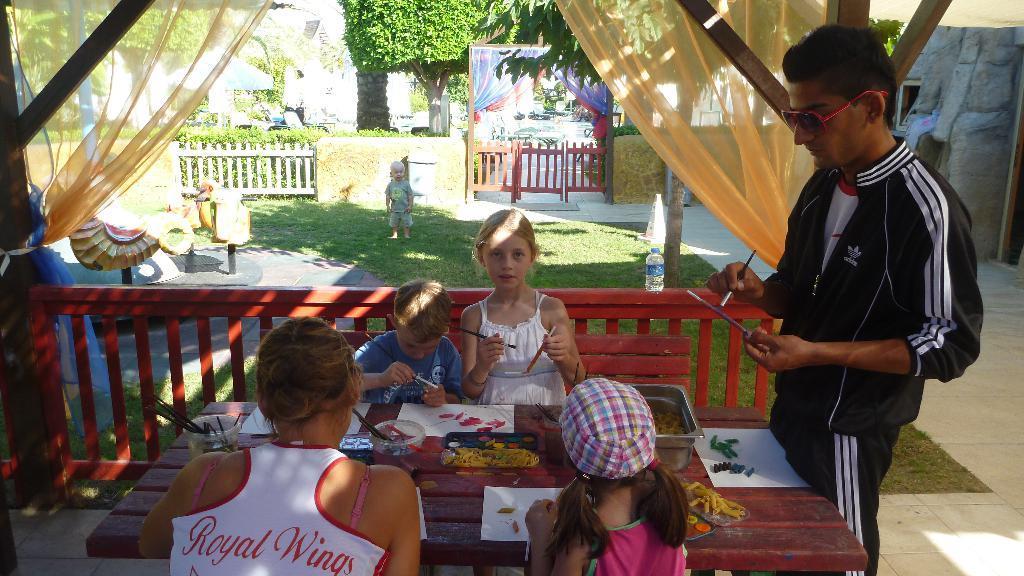Describe this image in one or two sentences. In this picture there are four kids sitting. Another standing. Beside her there is a lady. And a man with black color dress is stunning. In the background there is a grass , a baby, a doors , trees, fencing and curtains are there. 